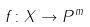Convert formula to latex. <formula><loc_0><loc_0><loc_500><loc_500>f \colon X \to P ^ { m }</formula> 